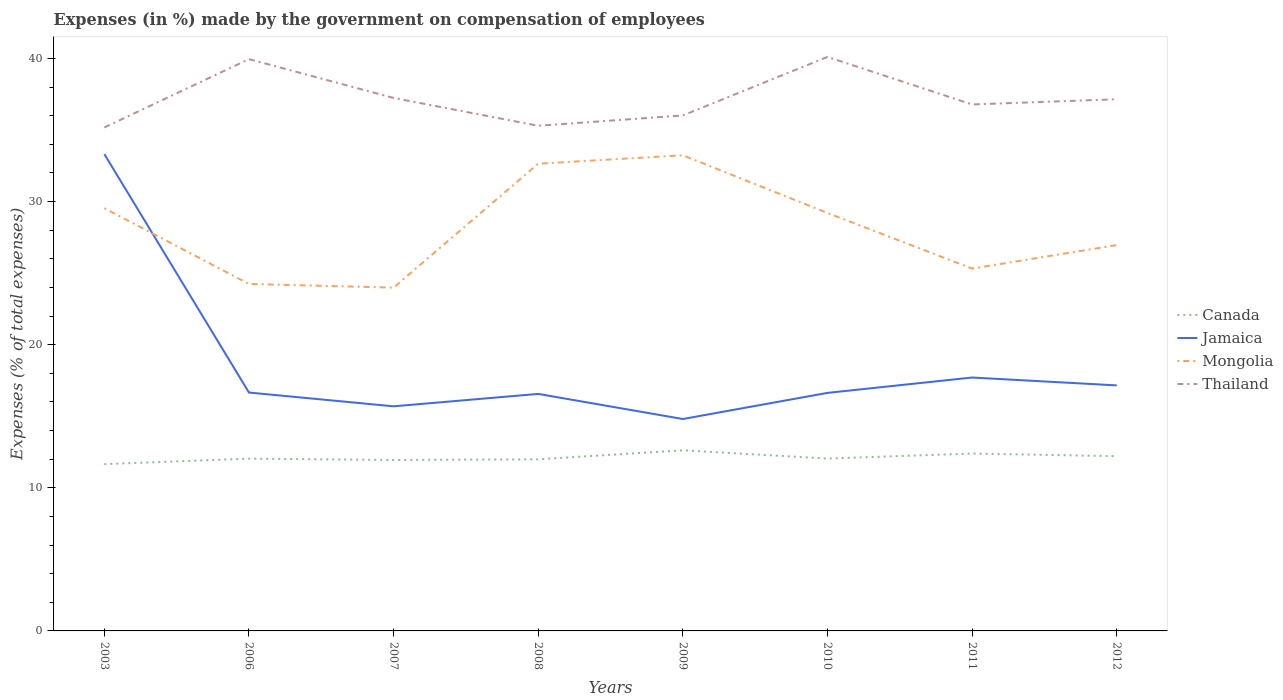Does the line corresponding to Canada intersect with the line corresponding to Jamaica?
Give a very brief answer. No. Across all years, what is the maximum percentage of expenses made by the government on compensation of employees in Jamaica?
Keep it short and to the point. 14.81. What is the total percentage of expenses made by the government on compensation of employees in Thailand in the graph?
Make the answer very short. 0.09. What is the difference between the highest and the second highest percentage of expenses made by the government on compensation of employees in Canada?
Your response must be concise. 0.97. What is the difference between two consecutive major ticks on the Y-axis?
Provide a short and direct response. 10. Are the values on the major ticks of Y-axis written in scientific E-notation?
Make the answer very short. No. Does the graph contain any zero values?
Your answer should be very brief. No. Where does the legend appear in the graph?
Keep it short and to the point. Center right. How many legend labels are there?
Provide a succinct answer. 4. How are the legend labels stacked?
Give a very brief answer. Vertical. What is the title of the graph?
Offer a terse response. Expenses (in %) made by the government on compensation of employees. What is the label or title of the Y-axis?
Provide a succinct answer. Expenses (% of total expenses). What is the Expenses (% of total expenses) in Canada in 2003?
Ensure brevity in your answer.  11.66. What is the Expenses (% of total expenses) in Jamaica in 2003?
Your response must be concise. 33.32. What is the Expenses (% of total expenses) in Mongolia in 2003?
Your answer should be compact. 29.54. What is the Expenses (% of total expenses) of Thailand in 2003?
Your answer should be very brief. 35.18. What is the Expenses (% of total expenses) in Canada in 2006?
Provide a succinct answer. 12.04. What is the Expenses (% of total expenses) in Jamaica in 2006?
Your answer should be compact. 16.66. What is the Expenses (% of total expenses) of Mongolia in 2006?
Provide a succinct answer. 24.25. What is the Expenses (% of total expenses) in Thailand in 2006?
Keep it short and to the point. 39.95. What is the Expenses (% of total expenses) of Canada in 2007?
Provide a succinct answer. 11.95. What is the Expenses (% of total expenses) in Jamaica in 2007?
Ensure brevity in your answer.  15.69. What is the Expenses (% of total expenses) of Mongolia in 2007?
Ensure brevity in your answer.  23.99. What is the Expenses (% of total expenses) of Thailand in 2007?
Keep it short and to the point. 37.24. What is the Expenses (% of total expenses) in Canada in 2008?
Your response must be concise. 11.99. What is the Expenses (% of total expenses) in Jamaica in 2008?
Provide a short and direct response. 16.56. What is the Expenses (% of total expenses) in Mongolia in 2008?
Provide a succinct answer. 32.65. What is the Expenses (% of total expenses) in Thailand in 2008?
Your answer should be compact. 35.3. What is the Expenses (% of total expenses) of Canada in 2009?
Your answer should be very brief. 12.62. What is the Expenses (% of total expenses) of Jamaica in 2009?
Your answer should be compact. 14.81. What is the Expenses (% of total expenses) of Mongolia in 2009?
Your answer should be very brief. 33.24. What is the Expenses (% of total expenses) of Thailand in 2009?
Provide a short and direct response. 36.02. What is the Expenses (% of total expenses) in Canada in 2010?
Offer a terse response. 12.04. What is the Expenses (% of total expenses) of Jamaica in 2010?
Ensure brevity in your answer.  16.63. What is the Expenses (% of total expenses) in Mongolia in 2010?
Offer a very short reply. 29.21. What is the Expenses (% of total expenses) of Thailand in 2010?
Your answer should be compact. 40.11. What is the Expenses (% of total expenses) in Canada in 2011?
Keep it short and to the point. 12.39. What is the Expenses (% of total expenses) of Jamaica in 2011?
Your response must be concise. 17.71. What is the Expenses (% of total expenses) of Mongolia in 2011?
Your response must be concise. 25.32. What is the Expenses (% of total expenses) in Thailand in 2011?
Provide a succinct answer. 36.79. What is the Expenses (% of total expenses) of Canada in 2012?
Provide a succinct answer. 12.21. What is the Expenses (% of total expenses) of Jamaica in 2012?
Provide a short and direct response. 17.16. What is the Expenses (% of total expenses) in Mongolia in 2012?
Ensure brevity in your answer.  26.96. What is the Expenses (% of total expenses) in Thailand in 2012?
Your answer should be compact. 37.15. Across all years, what is the maximum Expenses (% of total expenses) of Canada?
Provide a succinct answer. 12.62. Across all years, what is the maximum Expenses (% of total expenses) of Jamaica?
Your response must be concise. 33.32. Across all years, what is the maximum Expenses (% of total expenses) in Mongolia?
Offer a very short reply. 33.24. Across all years, what is the maximum Expenses (% of total expenses) in Thailand?
Offer a terse response. 40.11. Across all years, what is the minimum Expenses (% of total expenses) in Canada?
Your response must be concise. 11.66. Across all years, what is the minimum Expenses (% of total expenses) of Jamaica?
Ensure brevity in your answer.  14.81. Across all years, what is the minimum Expenses (% of total expenses) of Mongolia?
Offer a very short reply. 23.99. Across all years, what is the minimum Expenses (% of total expenses) in Thailand?
Offer a very short reply. 35.18. What is the total Expenses (% of total expenses) in Canada in the graph?
Offer a terse response. 96.9. What is the total Expenses (% of total expenses) of Jamaica in the graph?
Your answer should be very brief. 148.54. What is the total Expenses (% of total expenses) in Mongolia in the graph?
Your response must be concise. 225.15. What is the total Expenses (% of total expenses) in Thailand in the graph?
Give a very brief answer. 297.74. What is the difference between the Expenses (% of total expenses) in Canada in 2003 and that in 2006?
Ensure brevity in your answer.  -0.38. What is the difference between the Expenses (% of total expenses) of Jamaica in 2003 and that in 2006?
Provide a short and direct response. 16.66. What is the difference between the Expenses (% of total expenses) of Mongolia in 2003 and that in 2006?
Your answer should be very brief. 5.29. What is the difference between the Expenses (% of total expenses) of Thailand in 2003 and that in 2006?
Keep it short and to the point. -4.78. What is the difference between the Expenses (% of total expenses) of Canada in 2003 and that in 2007?
Offer a terse response. -0.29. What is the difference between the Expenses (% of total expenses) in Jamaica in 2003 and that in 2007?
Your answer should be very brief. 17.63. What is the difference between the Expenses (% of total expenses) in Mongolia in 2003 and that in 2007?
Your answer should be compact. 5.55. What is the difference between the Expenses (% of total expenses) in Thailand in 2003 and that in 2007?
Offer a very short reply. -2.06. What is the difference between the Expenses (% of total expenses) in Canada in 2003 and that in 2008?
Offer a very short reply. -0.34. What is the difference between the Expenses (% of total expenses) in Jamaica in 2003 and that in 2008?
Ensure brevity in your answer.  16.76. What is the difference between the Expenses (% of total expenses) of Mongolia in 2003 and that in 2008?
Your answer should be compact. -3.11. What is the difference between the Expenses (% of total expenses) in Thailand in 2003 and that in 2008?
Your response must be concise. -0.12. What is the difference between the Expenses (% of total expenses) in Canada in 2003 and that in 2009?
Keep it short and to the point. -0.97. What is the difference between the Expenses (% of total expenses) in Jamaica in 2003 and that in 2009?
Provide a succinct answer. 18.51. What is the difference between the Expenses (% of total expenses) of Mongolia in 2003 and that in 2009?
Make the answer very short. -3.7. What is the difference between the Expenses (% of total expenses) in Thailand in 2003 and that in 2009?
Offer a terse response. -0.84. What is the difference between the Expenses (% of total expenses) of Canada in 2003 and that in 2010?
Offer a very short reply. -0.39. What is the difference between the Expenses (% of total expenses) of Jamaica in 2003 and that in 2010?
Ensure brevity in your answer.  16.69. What is the difference between the Expenses (% of total expenses) of Mongolia in 2003 and that in 2010?
Ensure brevity in your answer.  0.33. What is the difference between the Expenses (% of total expenses) of Thailand in 2003 and that in 2010?
Make the answer very short. -4.93. What is the difference between the Expenses (% of total expenses) of Canada in 2003 and that in 2011?
Ensure brevity in your answer.  -0.74. What is the difference between the Expenses (% of total expenses) of Jamaica in 2003 and that in 2011?
Your answer should be very brief. 15.61. What is the difference between the Expenses (% of total expenses) in Mongolia in 2003 and that in 2011?
Your answer should be very brief. 4.22. What is the difference between the Expenses (% of total expenses) of Thailand in 2003 and that in 2011?
Give a very brief answer. -1.61. What is the difference between the Expenses (% of total expenses) in Canada in 2003 and that in 2012?
Offer a terse response. -0.55. What is the difference between the Expenses (% of total expenses) in Jamaica in 2003 and that in 2012?
Provide a succinct answer. 16.16. What is the difference between the Expenses (% of total expenses) in Mongolia in 2003 and that in 2012?
Make the answer very short. 2.58. What is the difference between the Expenses (% of total expenses) of Thailand in 2003 and that in 2012?
Your answer should be compact. -1.97. What is the difference between the Expenses (% of total expenses) of Canada in 2006 and that in 2007?
Give a very brief answer. 0.09. What is the difference between the Expenses (% of total expenses) in Jamaica in 2006 and that in 2007?
Provide a short and direct response. 0.96. What is the difference between the Expenses (% of total expenses) of Mongolia in 2006 and that in 2007?
Your answer should be compact. 0.26. What is the difference between the Expenses (% of total expenses) in Thailand in 2006 and that in 2007?
Provide a succinct answer. 2.71. What is the difference between the Expenses (% of total expenses) of Canada in 2006 and that in 2008?
Offer a terse response. 0.05. What is the difference between the Expenses (% of total expenses) of Jamaica in 2006 and that in 2008?
Your answer should be very brief. 0.1. What is the difference between the Expenses (% of total expenses) of Mongolia in 2006 and that in 2008?
Provide a short and direct response. -8.4. What is the difference between the Expenses (% of total expenses) of Thailand in 2006 and that in 2008?
Keep it short and to the point. 4.66. What is the difference between the Expenses (% of total expenses) of Canada in 2006 and that in 2009?
Give a very brief answer. -0.58. What is the difference between the Expenses (% of total expenses) in Jamaica in 2006 and that in 2009?
Your answer should be compact. 1.85. What is the difference between the Expenses (% of total expenses) in Mongolia in 2006 and that in 2009?
Your answer should be compact. -8.99. What is the difference between the Expenses (% of total expenses) of Thailand in 2006 and that in 2009?
Ensure brevity in your answer.  3.93. What is the difference between the Expenses (% of total expenses) in Canada in 2006 and that in 2010?
Provide a short and direct response. -0. What is the difference between the Expenses (% of total expenses) of Jamaica in 2006 and that in 2010?
Ensure brevity in your answer.  0.02. What is the difference between the Expenses (% of total expenses) in Mongolia in 2006 and that in 2010?
Your response must be concise. -4.96. What is the difference between the Expenses (% of total expenses) in Thailand in 2006 and that in 2010?
Your response must be concise. -0.15. What is the difference between the Expenses (% of total expenses) in Canada in 2006 and that in 2011?
Ensure brevity in your answer.  -0.35. What is the difference between the Expenses (% of total expenses) of Jamaica in 2006 and that in 2011?
Provide a succinct answer. -1.05. What is the difference between the Expenses (% of total expenses) of Mongolia in 2006 and that in 2011?
Give a very brief answer. -1.07. What is the difference between the Expenses (% of total expenses) in Thailand in 2006 and that in 2011?
Keep it short and to the point. 3.17. What is the difference between the Expenses (% of total expenses) of Canada in 2006 and that in 2012?
Your response must be concise. -0.17. What is the difference between the Expenses (% of total expenses) of Jamaica in 2006 and that in 2012?
Your response must be concise. -0.5. What is the difference between the Expenses (% of total expenses) of Mongolia in 2006 and that in 2012?
Make the answer very short. -2.71. What is the difference between the Expenses (% of total expenses) of Thailand in 2006 and that in 2012?
Provide a succinct answer. 2.8. What is the difference between the Expenses (% of total expenses) in Canada in 2007 and that in 2008?
Give a very brief answer. -0.05. What is the difference between the Expenses (% of total expenses) in Jamaica in 2007 and that in 2008?
Ensure brevity in your answer.  -0.87. What is the difference between the Expenses (% of total expenses) in Mongolia in 2007 and that in 2008?
Provide a short and direct response. -8.66. What is the difference between the Expenses (% of total expenses) of Thailand in 2007 and that in 2008?
Your answer should be compact. 1.94. What is the difference between the Expenses (% of total expenses) in Canada in 2007 and that in 2009?
Offer a terse response. -0.67. What is the difference between the Expenses (% of total expenses) of Jamaica in 2007 and that in 2009?
Offer a terse response. 0.89. What is the difference between the Expenses (% of total expenses) of Mongolia in 2007 and that in 2009?
Your response must be concise. -9.25. What is the difference between the Expenses (% of total expenses) in Thailand in 2007 and that in 2009?
Your answer should be very brief. 1.22. What is the difference between the Expenses (% of total expenses) in Canada in 2007 and that in 2010?
Your answer should be compact. -0.1. What is the difference between the Expenses (% of total expenses) in Jamaica in 2007 and that in 2010?
Ensure brevity in your answer.  -0.94. What is the difference between the Expenses (% of total expenses) in Mongolia in 2007 and that in 2010?
Keep it short and to the point. -5.22. What is the difference between the Expenses (% of total expenses) in Thailand in 2007 and that in 2010?
Keep it short and to the point. -2.87. What is the difference between the Expenses (% of total expenses) of Canada in 2007 and that in 2011?
Offer a very short reply. -0.45. What is the difference between the Expenses (% of total expenses) of Jamaica in 2007 and that in 2011?
Provide a succinct answer. -2.01. What is the difference between the Expenses (% of total expenses) of Mongolia in 2007 and that in 2011?
Offer a very short reply. -1.33. What is the difference between the Expenses (% of total expenses) in Thailand in 2007 and that in 2011?
Provide a short and direct response. 0.45. What is the difference between the Expenses (% of total expenses) of Canada in 2007 and that in 2012?
Make the answer very short. -0.26. What is the difference between the Expenses (% of total expenses) of Jamaica in 2007 and that in 2012?
Your answer should be very brief. -1.46. What is the difference between the Expenses (% of total expenses) of Mongolia in 2007 and that in 2012?
Offer a very short reply. -2.97. What is the difference between the Expenses (% of total expenses) in Thailand in 2007 and that in 2012?
Your answer should be very brief. 0.09. What is the difference between the Expenses (% of total expenses) in Canada in 2008 and that in 2009?
Offer a very short reply. -0.63. What is the difference between the Expenses (% of total expenses) in Jamaica in 2008 and that in 2009?
Provide a short and direct response. 1.75. What is the difference between the Expenses (% of total expenses) in Mongolia in 2008 and that in 2009?
Ensure brevity in your answer.  -0.59. What is the difference between the Expenses (% of total expenses) in Thailand in 2008 and that in 2009?
Make the answer very short. -0.72. What is the difference between the Expenses (% of total expenses) in Canada in 2008 and that in 2010?
Offer a terse response. -0.05. What is the difference between the Expenses (% of total expenses) in Jamaica in 2008 and that in 2010?
Offer a very short reply. -0.07. What is the difference between the Expenses (% of total expenses) of Mongolia in 2008 and that in 2010?
Give a very brief answer. 3.44. What is the difference between the Expenses (% of total expenses) in Thailand in 2008 and that in 2010?
Offer a very short reply. -4.81. What is the difference between the Expenses (% of total expenses) in Canada in 2008 and that in 2011?
Make the answer very short. -0.4. What is the difference between the Expenses (% of total expenses) in Jamaica in 2008 and that in 2011?
Your response must be concise. -1.15. What is the difference between the Expenses (% of total expenses) in Mongolia in 2008 and that in 2011?
Provide a short and direct response. 7.33. What is the difference between the Expenses (% of total expenses) of Thailand in 2008 and that in 2011?
Your answer should be compact. -1.49. What is the difference between the Expenses (% of total expenses) in Canada in 2008 and that in 2012?
Your answer should be compact. -0.22. What is the difference between the Expenses (% of total expenses) of Jamaica in 2008 and that in 2012?
Your response must be concise. -0.6. What is the difference between the Expenses (% of total expenses) of Mongolia in 2008 and that in 2012?
Your answer should be compact. 5.69. What is the difference between the Expenses (% of total expenses) of Thailand in 2008 and that in 2012?
Ensure brevity in your answer.  -1.86. What is the difference between the Expenses (% of total expenses) of Canada in 2009 and that in 2010?
Ensure brevity in your answer.  0.58. What is the difference between the Expenses (% of total expenses) in Jamaica in 2009 and that in 2010?
Offer a terse response. -1.83. What is the difference between the Expenses (% of total expenses) of Mongolia in 2009 and that in 2010?
Provide a succinct answer. 4.03. What is the difference between the Expenses (% of total expenses) in Thailand in 2009 and that in 2010?
Provide a succinct answer. -4.09. What is the difference between the Expenses (% of total expenses) in Canada in 2009 and that in 2011?
Give a very brief answer. 0.23. What is the difference between the Expenses (% of total expenses) of Mongolia in 2009 and that in 2011?
Offer a very short reply. 7.92. What is the difference between the Expenses (% of total expenses) of Thailand in 2009 and that in 2011?
Your answer should be very brief. -0.77. What is the difference between the Expenses (% of total expenses) in Canada in 2009 and that in 2012?
Make the answer very short. 0.41. What is the difference between the Expenses (% of total expenses) of Jamaica in 2009 and that in 2012?
Provide a short and direct response. -2.35. What is the difference between the Expenses (% of total expenses) of Mongolia in 2009 and that in 2012?
Provide a short and direct response. 6.28. What is the difference between the Expenses (% of total expenses) of Thailand in 2009 and that in 2012?
Your response must be concise. -1.13. What is the difference between the Expenses (% of total expenses) in Canada in 2010 and that in 2011?
Give a very brief answer. -0.35. What is the difference between the Expenses (% of total expenses) in Jamaica in 2010 and that in 2011?
Your answer should be very brief. -1.07. What is the difference between the Expenses (% of total expenses) in Mongolia in 2010 and that in 2011?
Ensure brevity in your answer.  3.89. What is the difference between the Expenses (% of total expenses) of Thailand in 2010 and that in 2011?
Your answer should be very brief. 3.32. What is the difference between the Expenses (% of total expenses) in Canada in 2010 and that in 2012?
Provide a short and direct response. -0.17. What is the difference between the Expenses (% of total expenses) in Jamaica in 2010 and that in 2012?
Provide a succinct answer. -0.52. What is the difference between the Expenses (% of total expenses) in Mongolia in 2010 and that in 2012?
Your answer should be compact. 2.25. What is the difference between the Expenses (% of total expenses) in Thailand in 2010 and that in 2012?
Provide a succinct answer. 2.96. What is the difference between the Expenses (% of total expenses) in Canada in 2011 and that in 2012?
Ensure brevity in your answer.  0.18. What is the difference between the Expenses (% of total expenses) in Jamaica in 2011 and that in 2012?
Give a very brief answer. 0.55. What is the difference between the Expenses (% of total expenses) in Mongolia in 2011 and that in 2012?
Offer a terse response. -1.64. What is the difference between the Expenses (% of total expenses) in Thailand in 2011 and that in 2012?
Your response must be concise. -0.37. What is the difference between the Expenses (% of total expenses) in Canada in 2003 and the Expenses (% of total expenses) in Jamaica in 2006?
Offer a very short reply. -5. What is the difference between the Expenses (% of total expenses) of Canada in 2003 and the Expenses (% of total expenses) of Mongolia in 2006?
Give a very brief answer. -12.59. What is the difference between the Expenses (% of total expenses) in Canada in 2003 and the Expenses (% of total expenses) in Thailand in 2006?
Offer a terse response. -28.3. What is the difference between the Expenses (% of total expenses) in Jamaica in 2003 and the Expenses (% of total expenses) in Mongolia in 2006?
Your answer should be compact. 9.07. What is the difference between the Expenses (% of total expenses) of Jamaica in 2003 and the Expenses (% of total expenses) of Thailand in 2006?
Provide a short and direct response. -6.63. What is the difference between the Expenses (% of total expenses) of Mongolia in 2003 and the Expenses (% of total expenses) of Thailand in 2006?
Your answer should be very brief. -10.42. What is the difference between the Expenses (% of total expenses) of Canada in 2003 and the Expenses (% of total expenses) of Jamaica in 2007?
Keep it short and to the point. -4.04. What is the difference between the Expenses (% of total expenses) in Canada in 2003 and the Expenses (% of total expenses) in Mongolia in 2007?
Make the answer very short. -12.33. What is the difference between the Expenses (% of total expenses) in Canada in 2003 and the Expenses (% of total expenses) in Thailand in 2007?
Keep it short and to the point. -25.59. What is the difference between the Expenses (% of total expenses) of Jamaica in 2003 and the Expenses (% of total expenses) of Mongolia in 2007?
Offer a very short reply. 9.33. What is the difference between the Expenses (% of total expenses) of Jamaica in 2003 and the Expenses (% of total expenses) of Thailand in 2007?
Your answer should be very brief. -3.92. What is the difference between the Expenses (% of total expenses) of Mongolia in 2003 and the Expenses (% of total expenses) of Thailand in 2007?
Keep it short and to the point. -7.7. What is the difference between the Expenses (% of total expenses) of Canada in 2003 and the Expenses (% of total expenses) of Jamaica in 2008?
Offer a terse response. -4.91. What is the difference between the Expenses (% of total expenses) in Canada in 2003 and the Expenses (% of total expenses) in Mongolia in 2008?
Make the answer very short. -20.99. What is the difference between the Expenses (% of total expenses) of Canada in 2003 and the Expenses (% of total expenses) of Thailand in 2008?
Give a very brief answer. -23.64. What is the difference between the Expenses (% of total expenses) of Jamaica in 2003 and the Expenses (% of total expenses) of Mongolia in 2008?
Provide a succinct answer. 0.67. What is the difference between the Expenses (% of total expenses) of Jamaica in 2003 and the Expenses (% of total expenses) of Thailand in 2008?
Ensure brevity in your answer.  -1.98. What is the difference between the Expenses (% of total expenses) in Mongolia in 2003 and the Expenses (% of total expenses) in Thailand in 2008?
Keep it short and to the point. -5.76. What is the difference between the Expenses (% of total expenses) in Canada in 2003 and the Expenses (% of total expenses) in Jamaica in 2009?
Ensure brevity in your answer.  -3.15. What is the difference between the Expenses (% of total expenses) in Canada in 2003 and the Expenses (% of total expenses) in Mongolia in 2009?
Offer a terse response. -21.58. What is the difference between the Expenses (% of total expenses) in Canada in 2003 and the Expenses (% of total expenses) in Thailand in 2009?
Make the answer very short. -24.37. What is the difference between the Expenses (% of total expenses) of Jamaica in 2003 and the Expenses (% of total expenses) of Mongolia in 2009?
Provide a short and direct response. 0.08. What is the difference between the Expenses (% of total expenses) of Jamaica in 2003 and the Expenses (% of total expenses) of Thailand in 2009?
Keep it short and to the point. -2.7. What is the difference between the Expenses (% of total expenses) in Mongolia in 2003 and the Expenses (% of total expenses) in Thailand in 2009?
Give a very brief answer. -6.48. What is the difference between the Expenses (% of total expenses) in Canada in 2003 and the Expenses (% of total expenses) in Jamaica in 2010?
Your answer should be very brief. -4.98. What is the difference between the Expenses (% of total expenses) in Canada in 2003 and the Expenses (% of total expenses) in Mongolia in 2010?
Your response must be concise. -17.55. What is the difference between the Expenses (% of total expenses) in Canada in 2003 and the Expenses (% of total expenses) in Thailand in 2010?
Make the answer very short. -28.45. What is the difference between the Expenses (% of total expenses) of Jamaica in 2003 and the Expenses (% of total expenses) of Mongolia in 2010?
Provide a succinct answer. 4.11. What is the difference between the Expenses (% of total expenses) in Jamaica in 2003 and the Expenses (% of total expenses) in Thailand in 2010?
Provide a succinct answer. -6.79. What is the difference between the Expenses (% of total expenses) of Mongolia in 2003 and the Expenses (% of total expenses) of Thailand in 2010?
Your answer should be compact. -10.57. What is the difference between the Expenses (% of total expenses) in Canada in 2003 and the Expenses (% of total expenses) in Jamaica in 2011?
Offer a very short reply. -6.05. What is the difference between the Expenses (% of total expenses) in Canada in 2003 and the Expenses (% of total expenses) in Mongolia in 2011?
Your answer should be very brief. -13.67. What is the difference between the Expenses (% of total expenses) of Canada in 2003 and the Expenses (% of total expenses) of Thailand in 2011?
Make the answer very short. -25.13. What is the difference between the Expenses (% of total expenses) in Jamaica in 2003 and the Expenses (% of total expenses) in Mongolia in 2011?
Provide a succinct answer. 8. What is the difference between the Expenses (% of total expenses) in Jamaica in 2003 and the Expenses (% of total expenses) in Thailand in 2011?
Provide a succinct answer. -3.47. What is the difference between the Expenses (% of total expenses) of Mongolia in 2003 and the Expenses (% of total expenses) of Thailand in 2011?
Keep it short and to the point. -7.25. What is the difference between the Expenses (% of total expenses) in Canada in 2003 and the Expenses (% of total expenses) in Jamaica in 2012?
Keep it short and to the point. -5.5. What is the difference between the Expenses (% of total expenses) in Canada in 2003 and the Expenses (% of total expenses) in Mongolia in 2012?
Your response must be concise. -15.31. What is the difference between the Expenses (% of total expenses) in Canada in 2003 and the Expenses (% of total expenses) in Thailand in 2012?
Make the answer very short. -25.5. What is the difference between the Expenses (% of total expenses) in Jamaica in 2003 and the Expenses (% of total expenses) in Mongolia in 2012?
Offer a terse response. 6.36. What is the difference between the Expenses (% of total expenses) of Jamaica in 2003 and the Expenses (% of total expenses) of Thailand in 2012?
Provide a succinct answer. -3.83. What is the difference between the Expenses (% of total expenses) in Mongolia in 2003 and the Expenses (% of total expenses) in Thailand in 2012?
Offer a very short reply. -7.61. What is the difference between the Expenses (% of total expenses) of Canada in 2006 and the Expenses (% of total expenses) of Jamaica in 2007?
Offer a very short reply. -3.65. What is the difference between the Expenses (% of total expenses) in Canada in 2006 and the Expenses (% of total expenses) in Mongolia in 2007?
Your answer should be very brief. -11.95. What is the difference between the Expenses (% of total expenses) of Canada in 2006 and the Expenses (% of total expenses) of Thailand in 2007?
Keep it short and to the point. -25.2. What is the difference between the Expenses (% of total expenses) of Jamaica in 2006 and the Expenses (% of total expenses) of Mongolia in 2007?
Provide a succinct answer. -7.33. What is the difference between the Expenses (% of total expenses) of Jamaica in 2006 and the Expenses (% of total expenses) of Thailand in 2007?
Offer a terse response. -20.58. What is the difference between the Expenses (% of total expenses) in Mongolia in 2006 and the Expenses (% of total expenses) in Thailand in 2007?
Keep it short and to the point. -13. What is the difference between the Expenses (% of total expenses) of Canada in 2006 and the Expenses (% of total expenses) of Jamaica in 2008?
Offer a very short reply. -4.52. What is the difference between the Expenses (% of total expenses) in Canada in 2006 and the Expenses (% of total expenses) in Mongolia in 2008?
Keep it short and to the point. -20.61. What is the difference between the Expenses (% of total expenses) in Canada in 2006 and the Expenses (% of total expenses) in Thailand in 2008?
Offer a very short reply. -23.26. What is the difference between the Expenses (% of total expenses) of Jamaica in 2006 and the Expenses (% of total expenses) of Mongolia in 2008?
Offer a very short reply. -15.99. What is the difference between the Expenses (% of total expenses) of Jamaica in 2006 and the Expenses (% of total expenses) of Thailand in 2008?
Offer a terse response. -18.64. What is the difference between the Expenses (% of total expenses) of Mongolia in 2006 and the Expenses (% of total expenses) of Thailand in 2008?
Provide a short and direct response. -11.05. What is the difference between the Expenses (% of total expenses) in Canada in 2006 and the Expenses (% of total expenses) in Jamaica in 2009?
Ensure brevity in your answer.  -2.77. What is the difference between the Expenses (% of total expenses) in Canada in 2006 and the Expenses (% of total expenses) in Mongolia in 2009?
Make the answer very short. -21.2. What is the difference between the Expenses (% of total expenses) of Canada in 2006 and the Expenses (% of total expenses) of Thailand in 2009?
Your response must be concise. -23.98. What is the difference between the Expenses (% of total expenses) in Jamaica in 2006 and the Expenses (% of total expenses) in Mongolia in 2009?
Your response must be concise. -16.58. What is the difference between the Expenses (% of total expenses) in Jamaica in 2006 and the Expenses (% of total expenses) in Thailand in 2009?
Your response must be concise. -19.36. What is the difference between the Expenses (% of total expenses) of Mongolia in 2006 and the Expenses (% of total expenses) of Thailand in 2009?
Offer a very short reply. -11.78. What is the difference between the Expenses (% of total expenses) of Canada in 2006 and the Expenses (% of total expenses) of Jamaica in 2010?
Your response must be concise. -4.59. What is the difference between the Expenses (% of total expenses) in Canada in 2006 and the Expenses (% of total expenses) in Mongolia in 2010?
Your answer should be compact. -17.17. What is the difference between the Expenses (% of total expenses) in Canada in 2006 and the Expenses (% of total expenses) in Thailand in 2010?
Provide a short and direct response. -28.07. What is the difference between the Expenses (% of total expenses) in Jamaica in 2006 and the Expenses (% of total expenses) in Mongolia in 2010?
Provide a succinct answer. -12.55. What is the difference between the Expenses (% of total expenses) in Jamaica in 2006 and the Expenses (% of total expenses) in Thailand in 2010?
Make the answer very short. -23.45. What is the difference between the Expenses (% of total expenses) of Mongolia in 2006 and the Expenses (% of total expenses) of Thailand in 2010?
Offer a very short reply. -15.86. What is the difference between the Expenses (% of total expenses) of Canada in 2006 and the Expenses (% of total expenses) of Jamaica in 2011?
Provide a short and direct response. -5.67. What is the difference between the Expenses (% of total expenses) of Canada in 2006 and the Expenses (% of total expenses) of Mongolia in 2011?
Offer a very short reply. -13.28. What is the difference between the Expenses (% of total expenses) in Canada in 2006 and the Expenses (% of total expenses) in Thailand in 2011?
Your answer should be very brief. -24.75. What is the difference between the Expenses (% of total expenses) of Jamaica in 2006 and the Expenses (% of total expenses) of Mongolia in 2011?
Your answer should be compact. -8.66. What is the difference between the Expenses (% of total expenses) in Jamaica in 2006 and the Expenses (% of total expenses) in Thailand in 2011?
Provide a short and direct response. -20.13. What is the difference between the Expenses (% of total expenses) in Mongolia in 2006 and the Expenses (% of total expenses) in Thailand in 2011?
Provide a short and direct response. -12.54. What is the difference between the Expenses (% of total expenses) in Canada in 2006 and the Expenses (% of total expenses) in Jamaica in 2012?
Your answer should be very brief. -5.12. What is the difference between the Expenses (% of total expenses) in Canada in 2006 and the Expenses (% of total expenses) in Mongolia in 2012?
Your answer should be compact. -14.92. What is the difference between the Expenses (% of total expenses) of Canada in 2006 and the Expenses (% of total expenses) of Thailand in 2012?
Provide a succinct answer. -25.11. What is the difference between the Expenses (% of total expenses) of Jamaica in 2006 and the Expenses (% of total expenses) of Mongolia in 2012?
Keep it short and to the point. -10.3. What is the difference between the Expenses (% of total expenses) of Jamaica in 2006 and the Expenses (% of total expenses) of Thailand in 2012?
Make the answer very short. -20.5. What is the difference between the Expenses (% of total expenses) of Mongolia in 2006 and the Expenses (% of total expenses) of Thailand in 2012?
Keep it short and to the point. -12.91. What is the difference between the Expenses (% of total expenses) in Canada in 2007 and the Expenses (% of total expenses) in Jamaica in 2008?
Provide a short and direct response. -4.62. What is the difference between the Expenses (% of total expenses) of Canada in 2007 and the Expenses (% of total expenses) of Mongolia in 2008?
Your response must be concise. -20.7. What is the difference between the Expenses (% of total expenses) in Canada in 2007 and the Expenses (% of total expenses) in Thailand in 2008?
Your response must be concise. -23.35. What is the difference between the Expenses (% of total expenses) in Jamaica in 2007 and the Expenses (% of total expenses) in Mongolia in 2008?
Give a very brief answer. -16.95. What is the difference between the Expenses (% of total expenses) in Jamaica in 2007 and the Expenses (% of total expenses) in Thailand in 2008?
Provide a succinct answer. -19.6. What is the difference between the Expenses (% of total expenses) in Mongolia in 2007 and the Expenses (% of total expenses) in Thailand in 2008?
Ensure brevity in your answer.  -11.31. What is the difference between the Expenses (% of total expenses) of Canada in 2007 and the Expenses (% of total expenses) of Jamaica in 2009?
Provide a succinct answer. -2.86. What is the difference between the Expenses (% of total expenses) in Canada in 2007 and the Expenses (% of total expenses) in Mongolia in 2009?
Give a very brief answer. -21.29. What is the difference between the Expenses (% of total expenses) of Canada in 2007 and the Expenses (% of total expenses) of Thailand in 2009?
Your answer should be very brief. -24.07. What is the difference between the Expenses (% of total expenses) in Jamaica in 2007 and the Expenses (% of total expenses) in Mongolia in 2009?
Keep it short and to the point. -17.54. What is the difference between the Expenses (% of total expenses) in Jamaica in 2007 and the Expenses (% of total expenses) in Thailand in 2009?
Offer a terse response. -20.33. What is the difference between the Expenses (% of total expenses) in Mongolia in 2007 and the Expenses (% of total expenses) in Thailand in 2009?
Make the answer very short. -12.03. What is the difference between the Expenses (% of total expenses) of Canada in 2007 and the Expenses (% of total expenses) of Jamaica in 2010?
Your answer should be very brief. -4.69. What is the difference between the Expenses (% of total expenses) in Canada in 2007 and the Expenses (% of total expenses) in Mongolia in 2010?
Keep it short and to the point. -17.26. What is the difference between the Expenses (% of total expenses) of Canada in 2007 and the Expenses (% of total expenses) of Thailand in 2010?
Ensure brevity in your answer.  -28.16. What is the difference between the Expenses (% of total expenses) of Jamaica in 2007 and the Expenses (% of total expenses) of Mongolia in 2010?
Offer a very short reply. -13.51. What is the difference between the Expenses (% of total expenses) of Jamaica in 2007 and the Expenses (% of total expenses) of Thailand in 2010?
Provide a succinct answer. -24.41. What is the difference between the Expenses (% of total expenses) in Mongolia in 2007 and the Expenses (% of total expenses) in Thailand in 2010?
Give a very brief answer. -16.12. What is the difference between the Expenses (% of total expenses) of Canada in 2007 and the Expenses (% of total expenses) of Jamaica in 2011?
Offer a terse response. -5.76. What is the difference between the Expenses (% of total expenses) of Canada in 2007 and the Expenses (% of total expenses) of Mongolia in 2011?
Keep it short and to the point. -13.37. What is the difference between the Expenses (% of total expenses) of Canada in 2007 and the Expenses (% of total expenses) of Thailand in 2011?
Offer a terse response. -24.84. What is the difference between the Expenses (% of total expenses) in Jamaica in 2007 and the Expenses (% of total expenses) in Mongolia in 2011?
Your response must be concise. -9.63. What is the difference between the Expenses (% of total expenses) of Jamaica in 2007 and the Expenses (% of total expenses) of Thailand in 2011?
Give a very brief answer. -21.09. What is the difference between the Expenses (% of total expenses) in Mongolia in 2007 and the Expenses (% of total expenses) in Thailand in 2011?
Make the answer very short. -12.8. What is the difference between the Expenses (% of total expenses) in Canada in 2007 and the Expenses (% of total expenses) in Jamaica in 2012?
Ensure brevity in your answer.  -5.21. What is the difference between the Expenses (% of total expenses) in Canada in 2007 and the Expenses (% of total expenses) in Mongolia in 2012?
Provide a short and direct response. -15.01. What is the difference between the Expenses (% of total expenses) of Canada in 2007 and the Expenses (% of total expenses) of Thailand in 2012?
Provide a short and direct response. -25.21. What is the difference between the Expenses (% of total expenses) of Jamaica in 2007 and the Expenses (% of total expenses) of Mongolia in 2012?
Ensure brevity in your answer.  -11.27. What is the difference between the Expenses (% of total expenses) in Jamaica in 2007 and the Expenses (% of total expenses) in Thailand in 2012?
Ensure brevity in your answer.  -21.46. What is the difference between the Expenses (% of total expenses) in Mongolia in 2007 and the Expenses (% of total expenses) in Thailand in 2012?
Provide a succinct answer. -13.16. What is the difference between the Expenses (% of total expenses) in Canada in 2008 and the Expenses (% of total expenses) in Jamaica in 2009?
Offer a very short reply. -2.81. What is the difference between the Expenses (% of total expenses) of Canada in 2008 and the Expenses (% of total expenses) of Mongolia in 2009?
Ensure brevity in your answer.  -21.24. What is the difference between the Expenses (% of total expenses) of Canada in 2008 and the Expenses (% of total expenses) of Thailand in 2009?
Make the answer very short. -24.03. What is the difference between the Expenses (% of total expenses) of Jamaica in 2008 and the Expenses (% of total expenses) of Mongolia in 2009?
Make the answer very short. -16.67. What is the difference between the Expenses (% of total expenses) in Jamaica in 2008 and the Expenses (% of total expenses) in Thailand in 2009?
Give a very brief answer. -19.46. What is the difference between the Expenses (% of total expenses) in Mongolia in 2008 and the Expenses (% of total expenses) in Thailand in 2009?
Your response must be concise. -3.37. What is the difference between the Expenses (% of total expenses) in Canada in 2008 and the Expenses (% of total expenses) in Jamaica in 2010?
Your answer should be very brief. -4.64. What is the difference between the Expenses (% of total expenses) of Canada in 2008 and the Expenses (% of total expenses) of Mongolia in 2010?
Give a very brief answer. -17.21. What is the difference between the Expenses (% of total expenses) of Canada in 2008 and the Expenses (% of total expenses) of Thailand in 2010?
Offer a very short reply. -28.12. What is the difference between the Expenses (% of total expenses) of Jamaica in 2008 and the Expenses (% of total expenses) of Mongolia in 2010?
Your response must be concise. -12.64. What is the difference between the Expenses (% of total expenses) of Jamaica in 2008 and the Expenses (% of total expenses) of Thailand in 2010?
Provide a short and direct response. -23.55. What is the difference between the Expenses (% of total expenses) in Mongolia in 2008 and the Expenses (% of total expenses) in Thailand in 2010?
Your response must be concise. -7.46. What is the difference between the Expenses (% of total expenses) of Canada in 2008 and the Expenses (% of total expenses) of Jamaica in 2011?
Provide a succinct answer. -5.71. What is the difference between the Expenses (% of total expenses) in Canada in 2008 and the Expenses (% of total expenses) in Mongolia in 2011?
Provide a succinct answer. -13.33. What is the difference between the Expenses (% of total expenses) in Canada in 2008 and the Expenses (% of total expenses) in Thailand in 2011?
Make the answer very short. -24.8. What is the difference between the Expenses (% of total expenses) in Jamaica in 2008 and the Expenses (% of total expenses) in Mongolia in 2011?
Make the answer very short. -8.76. What is the difference between the Expenses (% of total expenses) in Jamaica in 2008 and the Expenses (% of total expenses) in Thailand in 2011?
Provide a short and direct response. -20.23. What is the difference between the Expenses (% of total expenses) of Mongolia in 2008 and the Expenses (% of total expenses) of Thailand in 2011?
Your answer should be very brief. -4.14. What is the difference between the Expenses (% of total expenses) in Canada in 2008 and the Expenses (% of total expenses) in Jamaica in 2012?
Make the answer very short. -5.16. What is the difference between the Expenses (% of total expenses) of Canada in 2008 and the Expenses (% of total expenses) of Mongolia in 2012?
Your response must be concise. -14.97. What is the difference between the Expenses (% of total expenses) in Canada in 2008 and the Expenses (% of total expenses) in Thailand in 2012?
Provide a short and direct response. -25.16. What is the difference between the Expenses (% of total expenses) of Jamaica in 2008 and the Expenses (% of total expenses) of Mongolia in 2012?
Your answer should be very brief. -10.4. What is the difference between the Expenses (% of total expenses) of Jamaica in 2008 and the Expenses (% of total expenses) of Thailand in 2012?
Provide a succinct answer. -20.59. What is the difference between the Expenses (% of total expenses) of Mongolia in 2008 and the Expenses (% of total expenses) of Thailand in 2012?
Provide a short and direct response. -4.5. What is the difference between the Expenses (% of total expenses) of Canada in 2009 and the Expenses (% of total expenses) of Jamaica in 2010?
Keep it short and to the point. -4.01. What is the difference between the Expenses (% of total expenses) of Canada in 2009 and the Expenses (% of total expenses) of Mongolia in 2010?
Provide a succinct answer. -16.59. What is the difference between the Expenses (% of total expenses) of Canada in 2009 and the Expenses (% of total expenses) of Thailand in 2010?
Give a very brief answer. -27.49. What is the difference between the Expenses (% of total expenses) of Jamaica in 2009 and the Expenses (% of total expenses) of Mongolia in 2010?
Your response must be concise. -14.4. What is the difference between the Expenses (% of total expenses) of Jamaica in 2009 and the Expenses (% of total expenses) of Thailand in 2010?
Ensure brevity in your answer.  -25.3. What is the difference between the Expenses (% of total expenses) in Mongolia in 2009 and the Expenses (% of total expenses) in Thailand in 2010?
Keep it short and to the point. -6.87. What is the difference between the Expenses (% of total expenses) in Canada in 2009 and the Expenses (% of total expenses) in Jamaica in 2011?
Your answer should be very brief. -5.09. What is the difference between the Expenses (% of total expenses) of Canada in 2009 and the Expenses (% of total expenses) of Mongolia in 2011?
Offer a terse response. -12.7. What is the difference between the Expenses (% of total expenses) in Canada in 2009 and the Expenses (% of total expenses) in Thailand in 2011?
Keep it short and to the point. -24.17. What is the difference between the Expenses (% of total expenses) in Jamaica in 2009 and the Expenses (% of total expenses) in Mongolia in 2011?
Your answer should be compact. -10.51. What is the difference between the Expenses (% of total expenses) of Jamaica in 2009 and the Expenses (% of total expenses) of Thailand in 2011?
Offer a terse response. -21.98. What is the difference between the Expenses (% of total expenses) in Mongolia in 2009 and the Expenses (% of total expenses) in Thailand in 2011?
Give a very brief answer. -3.55. What is the difference between the Expenses (% of total expenses) in Canada in 2009 and the Expenses (% of total expenses) in Jamaica in 2012?
Offer a very short reply. -4.54. What is the difference between the Expenses (% of total expenses) of Canada in 2009 and the Expenses (% of total expenses) of Mongolia in 2012?
Offer a very short reply. -14.34. What is the difference between the Expenses (% of total expenses) of Canada in 2009 and the Expenses (% of total expenses) of Thailand in 2012?
Provide a short and direct response. -24.53. What is the difference between the Expenses (% of total expenses) of Jamaica in 2009 and the Expenses (% of total expenses) of Mongolia in 2012?
Your answer should be very brief. -12.15. What is the difference between the Expenses (% of total expenses) of Jamaica in 2009 and the Expenses (% of total expenses) of Thailand in 2012?
Provide a short and direct response. -22.35. What is the difference between the Expenses (% of total expenses) in Mongolia in 2009 and the Expenses (% of total expenses) in Thailand in 2012?
Your answer should be very brief. -3.92. What is the difference between the Expenses (% of total expenses) in Canada in 2010 and the Expenses (% of total expenses) in Jamaica in 2011?
Keep it short and to the point. -5.66. What is the difference between the Expenses (% of total expenses) in Canada in 2010 and the Expenses (% of total expenses) in Mongolia in 2011?
Make the answer very short. -13.28. What is the difference between the Expenses (% of total expenses) in Canada in 2010 and the Expenses (% of total expenses) in Thailand in 2011?
Ensure brevity in your answer.  -24.74. What is the difference between the Expenses (% of total expenses) in Jamaica in 2010 and the Expenses (% of total expenses) in Mongolia in 2011?
Make the answer very short. -8.69. What is the difference between the Expenses (% of total expenses) in Jamaica in 2010 and the Expenses (% of total expenses) in Thailand in 2011?
Your answer should be compact. -20.15. What is the difference between the Expenses (% of total expenses) of Mongolia in 2010 and the Expenses (% of total expenses) of Thailand in 2011?
Provide a short and direct response. -7.58. What is the difference between the Expenses (% of total expenses) in Canada in 2010 and the Expenses (% of total expenses) in Jamaica in 2012?
Provide a succinct answer. -5.11. What is the difference between the Expenses (% of total expenses) of Canada in 2010 and the Expenses (% of total expenses) of Mongolia in 2012?
Provide a succinct answer. -14.92. What is the difference between the Expenses (% of total expenses) in Canada in 2010 and the Expenses (% of total expenses) in Thailand in 2012?
Offer a terse response. -25.11. What is the difference between the Expenses (% of total expenses) of Jamaica in 2010 and the Expenses (% of total expenses) of Mongolia in 2012?
Your answer should be compact. -10.33. What is the difference between the Expenses (% of total expenses) in Jamaica in 2010 and the Expenses (% of total expenses) in Thailand in 2012?
Your answer should be compact. -20.52. What is the difference between the Expenses (% of total expenses) of Mongolia in 2010 and the Expenses (% of total expenses) of Thailand in 2012?
Make the answer very short. -7.95. What is the difference between the Expenses (% of total expenses) in Canada in 2011 and the Expenses (% of total expenses) in Jamaica in 2012?
Give a very brief answer. -4.76. What is the difference between the Expenses (% of total expenses) in Canada in 2011 and the Expenses (% of total expenses) in Mongolia in 2012?
Offer a very short reply. -14.57. What is the difference between the Expenses (% of total expenses) of Canada in 2011 and the Expenses (% of total expenses) of Thailand in 2012?
Provide a succinct answer. -24.76. What is the difference between the Expenses (% of total expenses) of Jamaica in 2011 and the Expenses (% of total expenses) of Mongolia in 2012?
Provide a short and direct response. -9.25. What is the difference between the Expenses (% of total expenses) of Jamaica in 2011 and the Expenses (% of total expenses) of Thailand in 2012?
Ensure brevity in your answer.  -19.45. What is the difference between the Expenses (% of total expenses) in Mongolia in 2011 and the Expenses (% of total expenses) in Thailand in 2012?
Keep it short and to the point. -11.83. What is the average Expenses (% of total expenses) in Canada per year?
Keep it short and to the point. 12.11. What is the average Expenses (% of total expenses) in Jamaica per year?
Provide a succinct answer. 18.57. What is the average Expenses (% of total expenses) in Mongolia per year?
Your answer should be very brief. 28.14. What is the average Expenses (% of total expenses) of Thailand per year?
Provide a succinct answer. 37.22. In the year 2003, what is the difference between the Expenses (% of total expenses) in Canada and Expenses (% of total expenses) in Jamaica?
Provide a succinct answer. -21.67. In the year 2003, what is the difference between the Expenses (% of total expenses) of Canada and Expenses (% of total expenses) of Mongolia?
Your answer should be compact. -17.88. In the year 2003, what is the difference between the Expenses (% of total expenses) of Canada and Expenses (% of total expenses) of Thailand?
Ensure brevity in your answer.  -23.52. In the year 2003, what is the difference between the Expenses (% of total expenses) in Jamaica and Expenses (% of total expenses) in Mongolia?
Your answer should be very brief. 3.78. In the year 2003, what is the difference between the Expenses (% of total expenses) of Jamaica and Expenses (% of total expenses) of Thailand?
Offer a terse response. -1.86. In the year 2003, what is the difference between the Expenses (% of total expenses) in Mongolia and Expenses (% of total expenses) in Thailand?
Offer a terse response. -5.64. In the year 2006, what is the difference between the Expenses (% of total expenses) of Canada and Expenses (% of total expenses) of Jamaica?
Provide a short and direct response. -4.62. In the year 2006, what is the difference between the Expenses (% of total expenses) in Canada and Expenses (% of total expenses) in Mongolia?
Make the answer very short. -12.21. In the year 2006, what is the difference between the Expenses (% of total expenses) of Canada and Expenses (% of total expenses) of Thailand?
Your response must be concise. -27.91. In the year 2006, what is the difference between the Expenses (% of total expenses) of Jamaica and Expenses (% of total expenses) of Mongolia?
Provide a short and direct response. -7.59. In the year 2006, what is the difference between the Expenses (% of total expenses) of Jamaica and Expenses (% of total expenses) of Thailand?
Your answer should be compact. -23.3. In the year 2006, what is the difference between the Expenses (% of total expenses) of Mongolia and Expenses (% of total expenses) of Thailand?
Your answer should be very brief. -15.71. In the year 2007, what is the difference between the Expenses (% of total expenses) of Canada and Expenses (% of total expenses) of Jamaica?
Give a very brief answer. -3.75. In the year 2007, what is the difference between the Expenses (% of total expenses) of Canada and Expenses (% of total expenses) of Mongolia?
Keep it short and to the point. -12.04. In the year 2007, what is the difference between the Expenses (% of total expenses) in Canada and Expenses (% of total expenses) in Thailand?
Keep it short and to the point. -25.3. In the year 2007, what is the difference between the Expenses (% of total expenses) of Jamaica and Expenses (% of total expenses) of Mongolia?
Offer a very short reply. -8.29. In the year 2007, what is the difference between the Expenses (% of total expenses) of Jamaica and Expenses (% of total expenses) of Thailand?
Offer a terse response. -21.55. In the year 2007, what is the difference between the Expenses (% of total expenses) in Mongolia and Expenses (% of total expenses) in Thailand?
Your response must be concise. -13.25. In the year 2008, what is the difference between the Expenses (% of total expenses) in Canada and Expenses (% of total expenses) in Jamaica?
Offer a terse response. -4.57. In the year 2008, what is the difference between the Expenses (% of total expenses) in Canada and Expenses (% of total expenses) in Mongolia?
Your answer should be compact. -20.66. In the year 2008, what is the difference between the Expenses (% of total expenses) of Canada and Expenses (% of total expenses) of Thailand?
Provide a short and direct response. -23.31. In the year 2008, what is the difference between the Expenses (% of total expenses) in Jamaica and Expenses (% of total expenses) in Mongolia?
Make the answer very short. -16.09. In the year 2008, what is the difference between the Expenses (% of total expenses) of Jamaica and Expenses (% of total expenses) of Thailand?
Your answer should be very brief. -18.74. In the year 2008, what is the difference between the Expenses (% of total expenses) in Mongolia and Expenses (% of total expenses) in Thailand?
Offer a terse response. -2.65. In the year 2009, what is the difference between the Expenses (% of total expenses) of Canada and Expenses (% of total expenses) of Jamaica?
Give a very brief answer. -2.19. In the year 2009, what is the difference between the Expenses (% of total expenses) of Canada and Expenses (% of total expenses) of Mongolia?
Provide a succinct answer. -20.62. In the year 2009, what is the difference between the Expenses (% of total expenses) of Canada and Expenses (% of total expenses) of Thailand?
Provide a succinct answer. -23.4. In the year 2009, what is the difference between the Expenses (% of total expenses) in Jamaica and Expenses (% of total expenses) in Mongolia?
Provide a short and direct response. -18.43. In the year 2009, what is the difference between the Expenses (% of total expenses) of Jamaica and Expenses (% of total expenses) of Thailand?
Offer a terse response. -21.21. In the year 2009, what is the difference between the Expenses (% of total expenses) of Mongolia and Expenses (% of total expenses) of Thailand?
Give a very brief answer. -2.79. In the year 2010, what is the difference between the Expenses (% of total expenses) in Canada and Expenses (% of total expenses) in Jamaica?
Your answer should be very brief. -4.59. In the year 2010, what is the difference between the Expenses (% of total expenses) in Canada and Expenses (% of total expenses) in Mongolia?
Your answer should be very brief. -17.16. In the year 2010, what is the difference between the Expenses (% of total expenses) in Canada and Expenses (% of total expenses) in Thailand?
Provide a short and direct response. -28.06. In the year 2010, what is the difference between the Expenses (% of total expenses) in Jamaica and Expenses (% of total expenses) in Mongolia?
Keep it short and to the point. -12.57. In the year 2010, what is the difference between the Expenses (% of total expenses) in Jamaica and Expenses (% of total expenses) in Thailand?
Offer a very short reply. -23.48. In the year 2010, what is the difference between the Expenses (% of total expenses) of Mongolia and Expenses (% of total expenses) of Thailand?
Give a very brief answer. -10.9. In the year 2011, what is the difference between the Expenses (% of total expenses) of Canada and Expenses (% of total expenses) of Jamaica?
Offer a very short reply. -5.31. In the year 2011, what is the difference between the Expenses (% of total expenses) in Canada and Expenses (% of total expenses) in Mongolia?
Ensure brevity in your answer.  -12.93. In the year 2011, what is the difference between the Expenses (% of total expenses) of Canada and Expenses (% of total expenses) of Thailand?
Offer a terse response. -24.39. In the year 2011, what is the difference between the Expenses (% of total expenses) in Jamaica and Expenses (% of total expenses) in Mongolia?
Your response must be concise. -7.61. In the year 2011, what is the difference between the Expenses (% of total expenses) of Jamaica and Expenses (% of total expenses) of Thailand?
Offer a very short reply. -19.08. In the year 2011, what is the difference between the Expenses (% of total expenses) in Mongolia and Expenses (% of total expenses) in Thailand?
Provide a short and direct response. -11.47. In the year 2012, what is the difference between the Expenses (% of total expenses) of Canada and Expenses (% of total expenses) of Jamaica?
Make the answer very short. -4.95. In the year 2012, what is the difference between the Expenses (% of total expenses) of Canada and Expenses (% of total expenses) of Mongolia?
Keep it short and to the point. -14.75. In the year 2012, what is the difference between the Expenses (% of total expenses) in Canada and Expenses (% of total expenses) in Thailand?
Your response must be concise. -24.94. In the year 2012, what is the difference between the Expenses (% of total expenses) of Jamaica and Expenses (% of total expenses) of Mongolia?
Provide a succinct answer. -9.8. In the year 2012, what is the difference between the Expenses (% of total expenses) of Jamaica and Expenses (% of total expenses) of Thailand?
Provide a short and direct response. -20. In the year 2012, what is the difference between the Expenses (% of total expenses) in Mongolia and Expenses (% of total expenses) in Thailand?
Offer a terse response. -10.19. What is the ratio of the Expenses (% of total expenses) in Canada in 2003 to that in 2006?
Keep it short and to the point. 0.97. What is the ratio of the Expenses (% of total expenses) in Jamaica in 2003 to that in 2006?
Provide a succinct answer. 2. What is the ratio of the Expenses (% of total expenses) in Mongolia in 2003 to that in 2006?
Your answer should be very brief. 1.22. What is the ratio of the Expenses (% of total expenses) in Thailand in 2003 to that in 2006?
Your response must be concise. 0.88. What is the ratio of the Expenses (% of total expenses) in Canada in 2003 to that in 2007?
Make the answer very short. 0.98. What is the ratio of the Expenses (% of total expenses) in Jamaica in 2003 to that in 2007?
Offer a terse response. 2.12. What is the ratio of the Expenses (% of total expenses) of Mongolia in 2003 to that in 2007?
Offer a terse response. 1.23. What is the ratio of the Expenses (% of total expenses) in Thailand in 2003 to that in 2007?
Make the answer very short. 0.94. What is the ratio of the Expenses (% of total expenses) of Canada in 2003 to that in 2008?
Your answer should be compact. 0.97. What is the ratio of the Expenses (% of total expenses) of Jamaica in 2003 to that in 2008?
Make the answer very short. 2.01. What is the ratio of the Expenses (% of total expenses) in Mongolia in 2003 to that in 2008?
Ensure brevity in your answer.  0.9. What is the ratio of the Expenses (% of total expenses) of Thailand in 2003 to that in 2008?
Give a very brief answer. 1. What is the ratio of the Expenses (% of total expenses) in Canada in 2003 to that in 2009?
Ensure brevity in your answer.  0.92. What is the ratio of the Expenses (% of total expenses) of Jamaica in 2003 to that in 2009?
Keep it short and to the point. 2.25. What is the ratio of the Expenses (% of total expenses) of Mongolia in 2003 to that in 2009?
Provide a succinct answer. 0.89. What is the ratio of the Expenses (% of total expenses) in Thailand in 2003 to that in 2009?
Make the answer very short. 0.98. What is the ratio of the Expenses (% of total expenses) in Jamaica in 2003 to that in 2010?
Give a very brief answer. 2. What is the ratio of the Expenses (% of total expenses) in Mongolia in 2003 to that in 2010?
Offer a very short reply. 1.01. What is the ratio of the Expenses (% of total expenses) of Thailand in 2003 to that in 2010?
Your response must be concise. 0.88. What is the ratio of the Expenses (% of total expenses) of Canada in 2003 to that in 2011?
Offer a very short reply. 0.94. What is the ratio of the Expenses (% of total expenses) in Jamaica in 2003 to that in 2011?
Give a very brief answer. 1.88. What is the ratio of the Expenses (% of total expenses) in Mongolia in 2003 to that in 2011?
Provide a short and direct response. 1.17. What is the ratio of the Expenses (% of total expenses) in Thailand in 2003 to that in 2011?
Offer a very short reply. 0.96. What is the ratio of the Expenses (% of total expenses) in Canada in 2003 to that in 2012?
Make the answer very short. 0.95. What is the ratio of the Expenses (% of total expenses) in Jamaica in 2003 to that in 2012?
Your answer should be very brief. 1.94. What is the ratio of the Expenses (% of total expenses) of Mongolia in 2003 to that in 2012?
Your answer should be very brief. 1.1. What is the ratio of the Expenses (% of total expenses) of Thailand in 2003 to that in 2012?
Your answer should be very brief. 0.95. What is the ratio of the Expenses (% of total expenses) of Jamaica in 2006 to that in 2007?
Make the answer very short. 1.06. What is the ratio of the Expenses (% of total expenses) of Mongolia in 2006 to that in 2007?
Offer a terse response. 1.01. What is the ratio of the Expenses (% of total expenses) of Thailand in 2006 to that in 2007?
Provide a short and direct response. 1.07. What is the ratio of the Expenses (% of total expenses) of Jamaica in 2006 to that in 2008?
Offer a terse response. 1.01. What is the ratio of the Expenses (% of total expenses) in Mongolia in 2006 to that in 2008?
Your response must be concise. 0.74. What is the ratio of the Expenses (% of total expenses) in Thailand in 2006 to that in 2008?
Provide a succinct answer. 1.13. What is the ratio of the Expenses (% of total expenses) of Canada in 2006 to that in 2009?
Offer a terse response. 0.95. What is the ratio of the Expenses (% of total expenses) of Mongolia in 2006 to that in 2009?
Offer a very short reply. 0.73. What is the ratio of the Expenses (% of total expenses) of Thailand in 2006 to that in 2009?
Keep it short and to the point. 1.11. What is the ratio of the Expenses (% of total expenses) of Canada in 2006 to that in 2010?
Offer a terse response. 1. What is the ratio of the Expenses (% of total expenses) of Mongolia in 2006 to that in 2010?
Offer a very short reply. 0.83. What is the ratio of the Expenses (% of total expenses) in Canada in 2006 to that in 2011?
Offer a terse response. 0.97. What is the ratio of the Expenses (% of total expenses) in Jamaica in 2006 to that in 2011?
Provide a succinct answer. 0.94. What is the ratio of the Expenses (% of total expenses) of Mongolia in 2006 to that in 2011?
Your answer should be compact. 0.96. What is the ratio of the Expenses (% of total expenses) of Thailand in 2006 to that in 2011?
Your answer should be compact. 1.09. What is the ratio of the Expenses (% of total expenses) in Canada in 2006 to that in 2012?
Ensure brevity in your answer.  0.99. What is the ratio of the Expenses (% of total expenses) of Jamaica in 2006 to that in 2012?
Keep it short and to the point. 0.97. What is the ratio of the Expenses (% of total expenses) in Mongolia in 2006 to that in 2012?
Offer a terse response. 0.9. What is the ratio of the Expenses (% of total expenses) in Thailand in 2006 to that in 2012?
Ensure brevity in your answer.  1.08. What is the ratio of the Expenses (% of total expenses) of Canada in 2007 to that in 2008?
Your answer should be very brief. 1. What is the ratio of the Expenses (% of total expenses) of Jamaica in 2007 to that in 2008?
Your answer should be very brief. 0.95. What is the ratio of the Expenses (% of total expenses) of Mongolia in 2007 to that in 2008?
Your response must be concise. 0.73. What is the ratio of the Expenses (% of total expenses) of Thailand in 2007 to that in 2008?
Provide a succinct answer. 1.06. What is the ratio of the Expenses (% of total expenses) of Canada in 2007 to that in 2009?
Offer a terse response. 0.95. What is the ratio of the Expenses (% of total expenses) of Jamaica in 2007 to that in 2009?
Offer a terse response. 1.06. What is the ratio of the Expenses (% of total expenses) of Mongolia in 2007 to that in 2009?
Provide a short and direct response. 0.72. What is the ratio of the Expenses (% of total expenses) of Thailand in 2007 to that in 2009?
Make the answer very short. 1.03. What is the ratio of the Expenses (% of total expenses) of Canada in 2007 to that in 2010?
Make the answer very short. 0.99. What is the ratio of the Expenses (% of total expenses) in Jamaica in 2007 to that in 2010?
Keep it short and to the point. 0.94. What is the ratio of the Expenses (% of total expenses) in Mongolia in 2007 to that in 2010?
Your answer should be very brief. 0.82. What is the ratio of the Expenses (% of total expenses) of Thailand in 2007 to that in 2010?
Give a very brief answer. 0.93. What is the ratio of the Expenses (% of total expenses) in Canada in 2007 to that in 2011?
Offer a terse response. 0.96. What is the ratio of the Expenses (% of total expenses) of Jamaica in 2007 to that in 2011?
Your answer should be very brief. 0.89. What is the ratio of the Expenses (% of total expenses) in Thailand in 2007 to that in 2011?
Keep it short and to the point. 1.01. What is the ratio of the Expenses (% of total expenses) in Canada in 2007 to that in 2012?
Make the answer very short. 0.98. What is the ratio of the Expenses (% of total expenses) of Jamaica in 2007 to that in 2012?
Your response must be concise. 0.91. What is the ratio of the Expenses (% of total expenses) of Mongolia in 2007 to that in 2012?
Provide a succinct answer. 0.89. What is the ratio of the Expenses (% of total expenses) of Thailand in 2007 to that in 2012?
Give a very brief answer. 1. What is the ratio of the Expenses (% of total expenses) in Canada in 2008 to that in 2009?
Keep it short and to the point. 0.95. What is the ratio of the Expenses (% of total expenses) of Jamaica in 2008 to that in 2009?
Give a very brief answer. 1.12. What is the ratio of the Expenses (% of total expenses) of Mongolia in 2008 to that in 2009?
Make the answer very short. 0.98. What is the ratio of the Expenses (% of total expenses) of Thailand in 2008 to that in 2009?
Provide a succinct answer. 0.98. What is the ratio of the Expenses (% of total expenses) of Canada in 2008 to that in 2010?
Your response must be concise. 1. What is the ratio of the Expenses (% of total expenses) of Mongolia in 2008 to that in 2010?
Your response must be concise. 1.12. What is the ratio of the Expenses (% of total expenses) in Thailand in 2008 to that in 2010?
Keep it short and to the point. 0.88. What is the ratio of the Expenses (% of total expenses) of Canada in 2008 to that in 2011?
Offer a very short reply. 0.97. What is the ratio of the Expenses (% of total expenses) of Jamaica in 2008 to that in 2011?
Provide a succinct answer. 0.94. What is the ratio of the Expenses (% of total expenses) in Mongolia in 2008 to that in 2011?
Provide a succinct answer. 1.29. What is the ratio of the Expenses (% of total expenses) of Thailand in 2008 to that in 2011?
Keep it short and to the point. 0.96. What is the ratio of the Expenses (% of total expenses) in Canada in 2008 to that in 2012?
Ensure brevity in your answer.  0.98. What is the ratio of the Expenses (% of total expenses) in Jamaica in 2008 to that in 2012?
Keep it short and to the point. 0.97. What is the ratio of the Expenses (% of total expenses) in Mongolia in 2008 to that in 2012?
Provide a short and direct response. 1.21. What is the ratio of the Expenses (% of total expenses) of Thailand in 2008 to that in 2012?
Ensure brevity in your answer.  0.95. What is the ratio of the Expenses (% of total expenses) in Canada in 2009 to that in 2010?
Offer a terse response. 1.05. What is the ratio of the Expenses (% of total expenses) of Jamaica in 2009 to that in 2010?
Ensure brevity in your answer.  0.89. What is the ratio of the Expenses (% of total expenses) of Mongolia in 2009 to that in 2010?
Keep it short and to the point. 1.14. What is the ratio of the Expenses (% of total expenses) in Thailand in 2009 to that in 2010?
Your answer should be very brief. 0.9. What is the ratio of the Expenses (% of total expenses) in Canada in 2009 to that in 2011?
Make the answer very short. 1.02. What is the ratio of the Expenses (% of total expenses) of Jamaica in 2009 to that in 2011?
Your response must be concise. 0.84. What is the ratio of the Expenses (% of total expenses) of Mongolia in 2009 to that in 2011?
Provide a succinct answer. 1.31. What is the ratio of the Expenses (% of total expenses) of Thailand in 2009 to that in 2011?
Your answer should be very brief. 0.98. What is the ratio of the Expenses (% of total expenses) of Canada in 2009 to that in 2012?
Ensure brevity in your answer.  1.03. What is the ratio of the Expenses (% of total expenses) of Jamaica in 2009 to that in 2012?
Make the answer very short. 0.86. What is the ratio of the Expenses (% of total expenses) of Mongolia in 2009 to that in 2012?
Keep it short and to the point. 1.23. What is the ratio of the Expenses (% of total expenses) of Thailand in 2009 to that in 2012?
Offer a very short reply. 0.97. What is the ratio of the Expenses (% of total expenses) in Canada in 2010 to that in 2011?
Offer a very short reply. 0.97. What is the ratio of the Expenses (% of total expenses) in Jamaica in 2010 to that in 2011?
Provide a short and direct response. 0.94. What is the ratio of the Expenses (% of total expenses) in Mongolia in 2010 to that in 2011?
Your answer should be compact. 1.15. What is the ratio of the Expenses (% of total expenses) in Thailand in 2010 to that in 2011?
Give a very brief answer. 1.09. What is the ratio of the Expenses (% of total expenses) of Canada in 2010 to that in 2012?
Your answer should be compact. 0.99. What is the ratio of the Expenses (% of total expenses) in Jamaica in 2010 to that in 2012?
Your answer should be very brief. 0.97. What is the ratio of the Expenses (% of total expenses) in Mongolia in 2010 to that in 2012?
Offer a terse response. 1.08. What is the ratio of the Expenses (% of total expenses) of Thailand in 2010 to that in 2012?
Offer a terse response. 1.08. What is the ratio of the Expenses (% of total expenses) in Canada in 2011 to that in 2012?
Ensure brevity in your answer.  1.02. What is the ratio of the Expenses (% of total expenses) of Jamaica in 2011 to that in 2012?
Make the answer very short. 1.03. What is the ratio of the Expenses (% of total expenses) of Mongolia in 2011 to that in 2012?
Your answer should be very brief. 0.94. What is the ratio of the Expenses (% of total expenses) of Thailand in 2011 to that in 2012?
Provide a succinct answer. 0.99. What is the difference between the highest and the second highest Expenses (% of total expenses) of Canada?
Provide a succinct answer. 0.23. What is the difference between the highest and the second highest Expenses (% of total expenses) of Jamaica?
Your answer should be very brief. 15.61. What is the difference between the highest and the second highest Expenses (% of total expenses) of Mongolia?
Offer a terse response. 0.59. What is the difference between the highest and the second highest Expenses (% of total expenses) of Thailand?
Keep it short and to the point. 0.15. What is the difference between the highest and the lowest Expenses (% of total expenses) in Canada?
Offer a terse response. 0.97. What is the difference between the highest and the lowest Expenses (% of total expenses) in Jamaica?
Offer a terse response. 18.51. What is the difference between the highest and the lowest Expenses (% of total expenses) in Mongolia?
Offer a terse response. 9.25. What is the difference between the highest and the lowest Expenses (% of total expenses) of Thailand?
Your response must be concise. 4.93. 